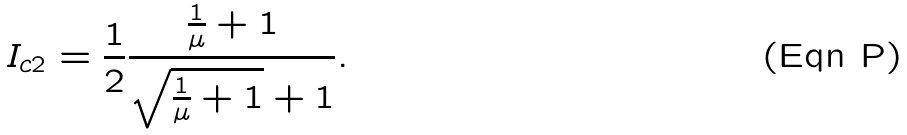Convert formula to latex. <formula><loc_0><loc_0><loc_500><loc_500>I _ { c 2 } = \frac { 1 } { 2 } \frac { \frac { 1 } { \mu } + 1 } { \sqrt { \frac { 1 } { \mu } + 1 } + 1 } .</formula> 